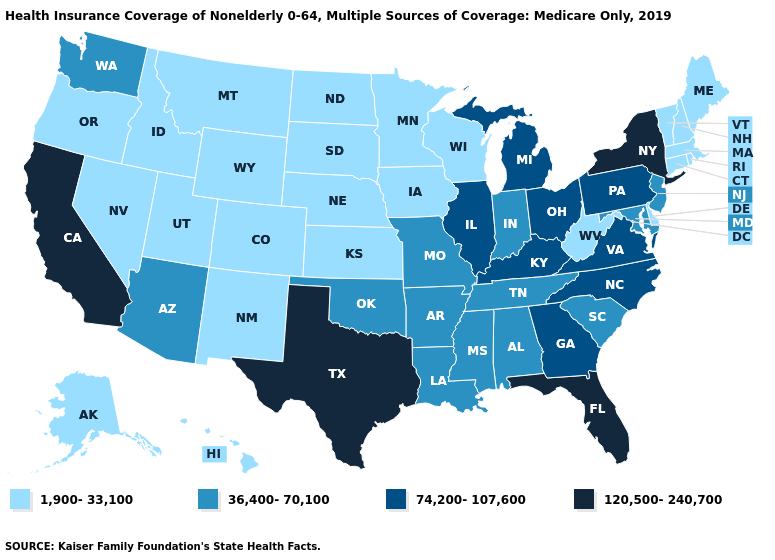Which states have the lowest value in the Northeast?
Quick response, please. Connecticut, Maine, Massachusetts, New Hampshire, Rhode Island, Vermont. What is the highest value in the USA?
Give a very brief answer. 120,500-240,700. Name the states that have a value in the range 74,200-107,600?
Quick response, please. Georgia, Illinois, Kentucky, Michigan, North Carolina, Ohio, Pennsylvania, Virginia. What is the value of California?
Give a very brief answer. 120,500-240,700. Does the first symbol in the legend represent the smallest category?
Write a very short answer. Yes. Name the states that have a value in the range 36,400-70,100?
Give a very brief answer. Alabama, Arizona, Arkansas, Indiana, Louisiana, Maryland, Mississippi, Missouri, New Jersey, Oklahoma, South Carolina, Tennessee, Washington. What is the value of South Dakota?
Write a very short answer. 1,900-33,100. Name the states that have a value in the range 36,400-70,100?
Short answer required. Alabama, Arizona, Arkansas, Indiana, Louisiana, Maryland, Mississippi, Missouri, New Jersey, Oklahoma, South Carolina, Tennessee, Washington. Does Texas have the highest value in the USA?
Answer briefly. Yes. Does Wyoming have the lowest value in the West?
Be succinct. Yes. How many symbols are there in the legend?
Answer briefly. 4. Among the states that border New Hampshire , which have the lowest value?
Write a very short answer. Maine, Massachusetts, Vermont. What is the value of West Virginia?
Answer briefly. 1,900-33,100. What is the lowest value in states that border Wyoming?
Be succinct. 1,900-33,100. What is the value of California?
Short answer required. 120,500-240,700. 